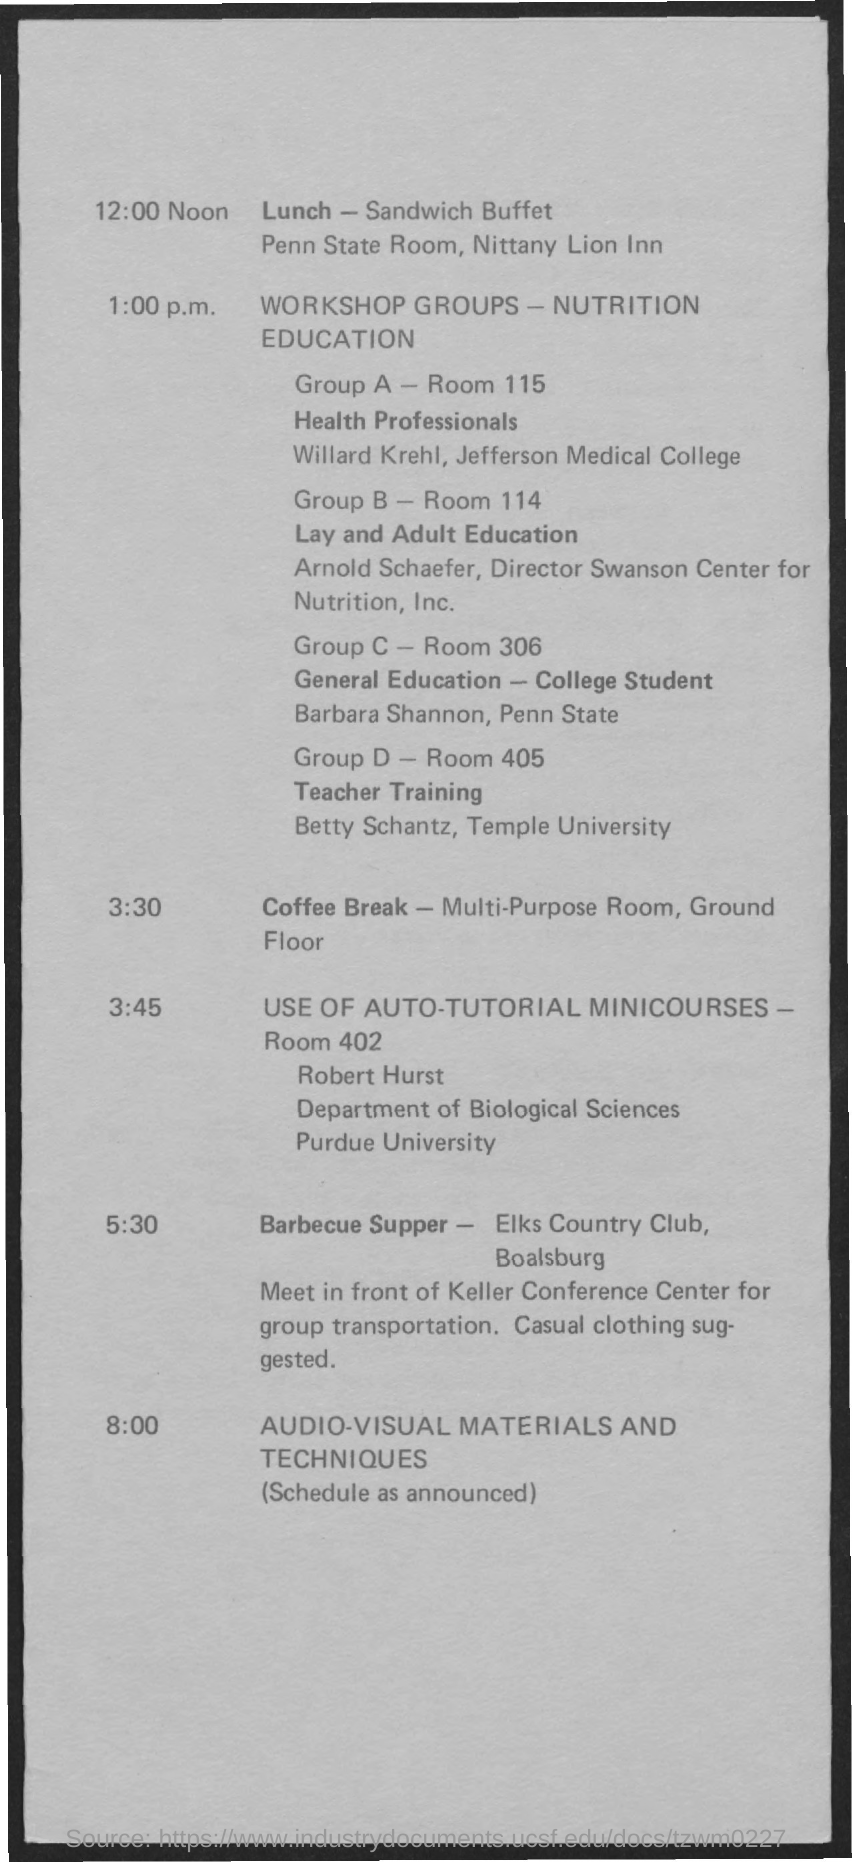Highlight a few significant elements in this photo. The room number of Group D is 405. It is currently 3:30 PM and the coffee break has commenced. The barbecue supper will take place at 5:30 PM. Lunch is scheduled to take place at 12:00 Noon. The room number of Group A is 115. 